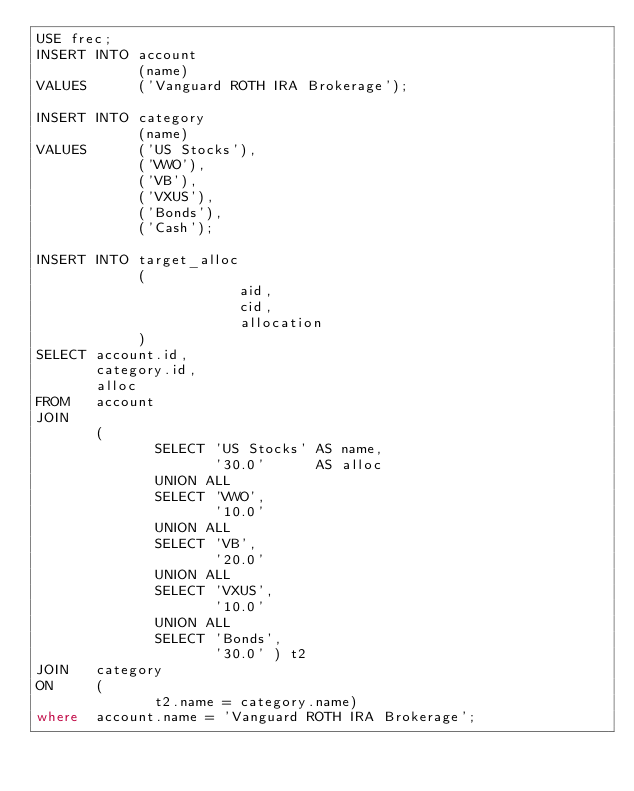<code> <loc_0><loc_0><loc_500><loc_500><_SQL_>USE frec;
INSERT INTO account 
            (name) 
VALUES      ('Vanguard ROTH IRA Brokerage'); 

INSERT INTO category 
            (name) 
VALUES      ('US Stocks'), 
            ('VWO'), 
            ('VB'), 
            ('VXUS'), 
            ('Bonds'), 
            ('Cash'); 

INSERT INTO target_alloc 
            ( 
                        aid, 
                        cid, 
                        allocation 
            ) 
SELECT account.id, 
       category.id, 
       alloc 
FROM   account 
JOIN 
       ( 
              SELECT 'US Stocks' AS name, 
                     '30.0'      AS alloc 
              UNION ALL 
              SELECT 'VWO', 
                     '10.0' 
              UNION ALL 
              SELECT 'VB', 
                     '20.0' 
              UNION ALL 
              SELECT 'VXUS', 
                     '10.0' 
              UNION ALL 
              SELECT 'Bonds', 
                     '30.0' ) t2 
JOIN   category 
ON     ( 
              t2.name = category.name) 
where  account.name = 'Vanguard ROTH IRA Brokerage';
</code> 